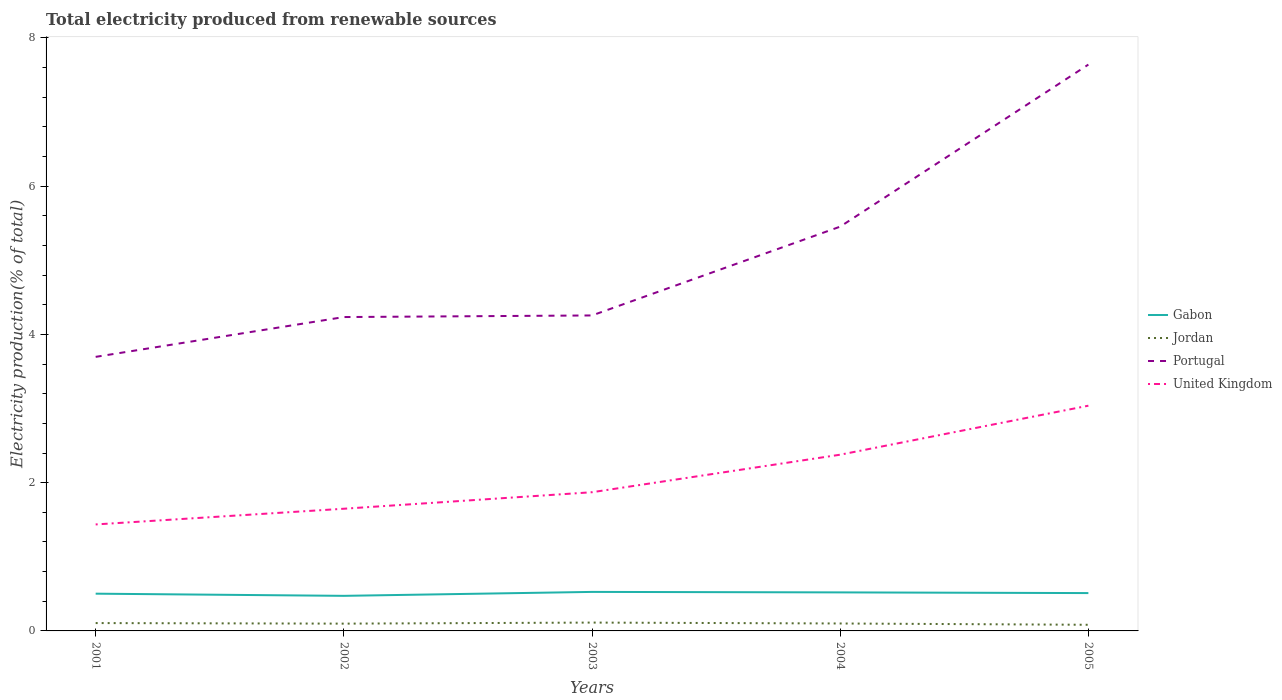How many different coloured lines are there?
Your answer should be compact. 4. Is the number of lines equal to the number of legend labels?
Make the answer very short. Yes. Across all years, what is the maximum total electricity produced in Jordan?
Give a very brief answer. 0.08. What is the total total electricity produced in Jordan in the graph?
Provide a short and direct response. 0.02. What is the difference between the highest and the second highest total electricity produced in Portugal?
Offer a terse response. 3.94. How many lines are there?
Provide a succinct answer. 4. How many years are there in the graph?
Make the answer very short. 5. How are the legend labels stacked?
Provide a succinct answer. Vertical. What is the title of the graph?
Your answer should be very brief. Total electricity produced from renewable sources. What is the label or title of the X-axis?
Provide a short and direct response. Years. What is the label or title of the Y-axis?
Your answer should be very brief. Electricity production(% of total). What is the Electricity production(% of total) of Gabon in 2001?
Your response must be concise. 0.5. What is the Electricity production(% of total) of Jordan in 2001?
Provide a short and direct response. 0.11. What is the Electricity production(% of total) in Portugal in 2001?
Give a very brief answer. 3.7. What is the Electricity production(% of total) in United Kingdom in 2001?
Ensure brevity in your answer.  1.44. What is the Electricity production(% of total) of Gabon in 2002?
Your response must be concise. 0.47. What is the Electricity production(% of total) of Jordan in 2002?
Make the answer very short. 0.1. What is the Electricity production(% of total) in Portugal in 2002?
Offer a very short reply. 4.23. What is the Electricity production(% of total) in United Kingdom in 2002?
Keep it short and to the point. 1.65. What is the Electricity production(% of total) of Gabon in 2003?
Offer a very short reply. 0.53. What is the Electricity production(% of total) of Jordan in 2003?
Your answer should be very brief. 0.11. What is the Electricity production(% of total) in Portugal in 2003?
Give a very brief answer. 4.26. What is the Electricity production(% of total) of United Kingdom in 2003?
Offer a terse response. 1.87. What is the Electricity production(% of total) in Gabon in 2004?
Provide a succinct answer. 0.52. What is the Electricity production(% of total) of Jordan in 2004?
Offer a terse response. 0.1. What is the Electricity production(% of total) in Portugal in 2004?
Offer a terse response. 5.45. What is the Electricity production(% of total) of United Kingdom in 2004?
Offer a terse response. 2.38. What is the Electricity production(% of total) of Gabon in 2005?
Provide a succinct answer. 0.51. What is the Electricity production(% of total) in Jordan in 2005?
Provide a short and direct response. 0.08. What is the Electricity production(% of total) of Portugal in 2005?
Your response must be concise. 7.64. What is the Electricity production(% of total) in United Kingdom in 2005?
Your answer should be very brief. 3.04. Across all years, what is the maximum Electricity production(% of total) of Gabon?
Provide a succinct answer. 0.53. Across all years, what is the maximum Electricity production(% of total) in Jordan?
Offer a very short reply. 0.11. Across all years, what is the maximum Electricity production(% of total) in Portugal?
Your answer should be compact. 7.64. Across all years, what is the maximum Electricity production(% of total) of United Kingdom?
Your response must be concise. 3.04. Across all years, what is the minimum Electricity production(% of total) in Gabon?
Offer a terse response. 0.47. Across all years, what is the minimum Electricity production(% of total) of Jordan?
Your answer should be compact. 0.08. Across all years, what is the minimum Electricity production(% of total) of Portugal?
Offer a very short reply. 3.7. Across all years, what is the minimum Electricity production(% of total) of United Kingdom?
Give a very brief answer. 1.44. What is the total Electricity production(% of total) in Gabon in the graph?
Ensure brevity in your answer.  2.53. What is the total Electricity production(% of total) in Jordan in the graph?
Provide a short and direct response. 0.5. What is the total Electricity production(% of total) in Portugal in the graph?
Your answer should be compact. 25.28. What is the total Electricity production(% of total) in United Kingdom in the graph?
Keep it short and to the point. 10.37. What is the difference between the Electricity production(% of total) in Gabon in 2001 and that in 2002?
Ensure brevity in your answer.  0.03. What is the difference between the Electricity production(% of total) of Jordan in 2001 and that in 2002?
Your answer should be very brief. 0.01. What is the difference between the Electricity production(% of total) of Portugal in 2001 and that in 2002?
Make the answer very short. -0.54. What is the difference between the Electricity production(% of total) in United Kingdom in 2001 and that in 2002?
Make the answer very short. -0.21. What is the difference between the Electricity production(% of total) of Gabon in 2001 and that in 2003?
Provide a succinct answer. -0.02. What is the difference between the Electricity production(% of total) of Jordan in 2001 and that in 2003?
Provide a succinct answer. -0.01. What is the difference between the Electricity production(% of total) of Portugal in 2001 and that in 2003?
Ensure brevity in your answer.  -0.56. What is the difference between the Electricity production(% of total) in United Kingdom in 2001 and that in 2003?
Your answer should be very brief. -0.43. What is the difference between the Electricity production(% of total) of Gabon in 2001 and that in 2004?
Offer a terse response. -0.02. What is the difference between the Electricity production(% of total) of Jordan in 2001 and that in 2004?
Make the answer very short. 0.01. What is the difference between the Electricity production(% of total) in Portugal in 2001 and that in 2004?
Give a very brief answer. -1.76. What is the difference between the Electricity production(% of total) of United Kingdom in 2001 and that in 2004?
Give a very brief answer. -0.94. What is the difference between the Electricity production(% of total) in Gabon in 2001 and that in 2005?
Provide a succinct answer. -0.01. What is the difference between the Electricity production(% of total) in Jordan in 2001 and that in 2005?
Keep it short and to the point. 0.02. What is the difference between the Electricity production(% of total) of Portugal in 2001 and that in 2005?
Your answer should be compact. -3.94. What is the difference between the Electricity production(% of total) in United Kingdom in 2001 and that in 2005?
Provide a succinct answer. -1.6. What is the difference between the Electricity production(% of total) in Gabon in 2002 and that in 2003?
Ensure brevity in your answer.  -0.05. What is the difference between the Electricity production(% of total) of Jordan in 2002 and that in 2003?
Your answer should be very brief. -0.01. What is the difference between the Electricity production(% of total) of Portugal in 2002 and that in 2003?
Keep it short and to the point. -0.02. What is the difference between the Electricity production(% of total) of United Kingdom in 2002 and that in 2003?
Keep it short and to the point. -0.22. What is the difference between the Electricity production(% of total) in Gabon in 2002 and that in 2004?
Your answer should be compact. -0.05. What is the difference between the Electricity production(% of total) in Jordan in 2002 and that in 2004?
Keep it short and to the point. -0. What is the difference between the Electricity production(% of total) in Portugal in 2002 and that in 2004?
Your answer should be very brief. -1.22. What is the difference between the Electricity production(% of total) in United Kingdom in 2002 and that in 2004?
Offer a terse response. -0.73. What is the difference between the Electricity production(% of total) of Gabon in 2002 and that in 2005?
Ensure brevity in your answer.  -0.04. What is the difference between the Electricity production(% of total) in Jordan in 2002 and that in 2005?
Provide a succinct answer. 0.02. What is the difference between the Electricity production(% of total) in Portugal in 2002 and that in 2005?
Your answer should be compact. -3.41. What is the difference between the Electricity production(% of total) in United Kingdom in 2002 and that in 2005?
Your answer should be compact. -1.39. What is the difference between the Electricity production(% of total) of Gabon in 2003 and that in 2004?
Provide a short and direct response. 0.01. What is the difference between the Electricity production(% of total) of Jordan in 2003 and that in 2004?
Ensure brevity in your answer.  0.01. What is the difference between the Electricity production(% of total) in Portugal in 2003 and that in 2004?
Keep it short and to the point. -1.2. What is the difference between the Electricity production(% of total) of United Kingdom in 2003 and that in 2004?
Provide a succinct answer. -0.51. What is the difference between the Electricity production(% of total) in Gabon in 2003 and that in 2005?
Your response must be concise. 0.02. What is the difference between the Electricity production(% of total) in Jordan in 2003 and that in 2005?
Provide a short and direct response. 0.03. What is the difference between the Electricity production(% of total) of Portugal in 2003 and that in 2005?
Provide a succinct answer. -3.38. What is the difference between the Electricity production(% of total) in United Kingdom in 2003 and that in 2005?
Your response must be concise. -1.17. What is the difference between the Electricity production(% of total) in Gabon in 2004 and that in 2005?
Ensure brevity in your answer.  0.01. What is the difference between the Electricity production(% of total) of Jordan in 2004 and that in 2005?
Your answer should be compact. 0.02. What is the difference between the Electricity production(% of total) in Portugal in 2004 and that in 2005?
Your response must be concise. -2.19. What is the difference between the Electricity production(% of total) in United Kingdom in 2004 and that in 2005?
Make the answer very short. -0.66. What is the difference between the Electricity production(% of total) in Gabon in 2001 and the Electricity production(% of total) in Jordan in 2002?
Your answer should be very brief. 0.4. What is the difference between the Electricity production(% of total) of Gabon in 2001 and the Electricity production(% of total) of Portugal in 2002?
Your answer should be compact. -3.73. What is the difference between the Electricity production(% of total) in Gabon in 2001 and the Electricity production(% of total) in United Kingdom in 2002?
Keep it short and to the point. -1.15. What is the difference between the Electricity production(% of total) of Jordan in 2001 and the Electricity production(% of total) of Portugal in 2002?
Ensure brevity in your answer.  -4.13. What is the difference between the Electricity production(% of total) in Jordan in 2001 and the Electricity production(% of total) in United Kingdom in 2002?
Offer a terse response. -1.54. What is the difference between the Electricity production(% of total) in Portugal in 2001 and the Electricity production(% of total) in United Kingdom in 2002?
Make the answer very short. 2.05. What is the difference between the Electricity production(% of total) of Gabon in 2001 and the Electricity production(% of total) of Jordan in 2003?
Keep it short and to the point. 0.39. What is the difference between the Electricity production(% of total) in Gabon in 2001 and the Electricity production(% of total) in Portugal in 2003?
Ensure brevity in your answer.  -3.75. What is the difference between the Electricity production(% of total) of Gabon in 2001 and the Electricity production(% of total) of United Kingdom in 2003?
Provide a short and direct response. -1.37. What is the difference between the Electricity production(% of total) of Jordan in 2001 and the Electricity production(% of total) of Portugal in 2003?
Offer a terse response. -4.15. What is the difference between the Electricity production(% of total) in Jordan in 2001 and the Electricity production(% of total) in United Kingdom in 2003?
Make the answer very short. -1.77. What is the difference between the Electricity production(% of total) of Portugal in 2001 and the Electricity production(% of total) of United Kingdom in 2003?
Provide a succinct answer. 1.83. What is the difference between the Electricity production(% of total) of Gabon in 2001 and the Electricity production(% of total) of Jordan in 2004?
Make the answer very short. 0.4. What is the difference between the Electricity production(% of total) of Gabon in 2001 and the Electricity production(% of total) of Portugal in 2004?
Your answer should be very brief. -4.95. What is the difference between the Electricity production(% of total) of Gabon in 2001 and the Electricity production(% of total) of United Kingdom in 2004?
Give a very brief answer. -1.88. What is the difference between the Electricity production(% of total) of Jordan in 2001 and the Electricity production(% of total) of Portugal in 2004?
Keep it short and to the point. -5.35. What is the difference between the Electricity production(% of total) of Jordan in 2001 and the Electricity production(% of total) of United Kingdom in 2004?
Make the answer very short. -2.27. What is the difference between the Electricity production(% of total) in Portugal in 2001 and the Electricity production(% of total) in United Kingdom in 2004?
Ensure brevity in your answer.  1.32. What is the difference between the Electricity production(% of total) of Gabon in 2001 and the Electricity production(% of total) of Jordan in 2005?
Offer a terse response. 0.42. What is the difference between the Electricity production(% of total) in Gabon in 2001 and the Electricity production(% of total) in Portugal in 2005?
Keep it short and to the point. -7.14. What is the difference between the Electricity production(% of total) of Gabon in 2001 and the Electricity production(% of total) of United Kingdom in 2005?
Make the answer very short. -2.54. What is the difference between the Electricity production(% of total) in Jordan in 2001 and the Electricity production(% of total) in Portugal in 2005?
Give a very brief answer. -7.53. What is the difference between the Electricity production(% of total) of Jordan in 2001 and the Electricity production(% of total) of United Kingdom in 2005?
Your answer should be compact. -2.93. What is the difference between the Electricity production(% of total) in Portugal in 2001 and the Electricity production(% of total) in United Kingdom in 2005?
Provide a succinct answer. 0.66. What is the difference between the Electricity production(% of total) of Gabon in 2002 and the Electricity production(% of total) of Jordan in 2003?
Keep it short and to the point. 0.36. What is the difference between the Electricity production(% of total) of Gabon in 2002 and the Electricity production(% of total) of Portugal in 2003?
Provide a succinct answer. -3.78. What is the difference between the Electricity production(% of total) of Gabon in 2002 and the Electricity production(% of total) of United Kingdom in 2003?
Make the answer very short. -1.4. What is the difference between the Electricity production(% of total) in Jordan in 2002 and the Electricity production(% of total) in Portugal in 2003?
Provide a succinct answer. -4.16. What is the difference between the Electricity production(% of total) of Jordan in 2002 and the Electricity production(% of total) of United Kingdom in 2003?
Your answer should be very brief. -1.77. What is the difference between the Electricity production(% of total) of Portugal in 2002 and the Electricity production(% of total) of United Kingdom in 2003?
Provide a short and direct response. 2.36. What is the difference between the Electricity production(% of total) in Gabon in 2002 and the Electricity production(% of total) in Jordan in 2004?
Keep it short and to the point. 0.37. What is the difference between the Electricity production(% of total) in Gabon in 2002 and the Electricity production(% of total) in Portugal in 2004?
Your answer should be very brief. -4.98. What is the difference between the Electricity production(% of total) in Gabon in 2002 and the Electricity production(% of total) in United Kingdom in 2004?
Your answer should be very brief. -1.9. What is the difference between the Electricity production(% of total) of Jordan in 2002 and the Electricity production(% of total) of Portugal in 2004?
Make the answer very short. -5.36. What is the difference between the Electricity production(% of total) of Jordan in 2002 and the Electricity production(% of total) of United Kingdom in 2004?
Your response must be concise. -2.28. What is the difference between the Electricity production(% of total) in Portugal in 2002 and the Electricity production(% of total) in United Kingdom in 2004?
Make the answer very short. 1.86. What is the difference between the Electricity production(% of total) in Gabon in 2002 and the Electricity production(% of total) in Jordan in 2005?
Offer a very short reply. 0.39. What is the difference between the Electricity production(% of total) of Gabon in 2002 and the Electricity production(% of total) of Portugal in 2005?
Offer a very short reply. -7.17. What is the difference between the Electricity production(% of total) of Gabon in 2002 and the Electricity production(% of total) of United Kingdom in 2005?
Give a very brief answer. -2.57. What is the difference between the Electricity production(% of total) of Jordan in 2002 and the Electricity production(% of total) of Portugal in 2005?
Provide a short and direct response. -7.54. What is the difference between the Electricity production(% of total) of Jordan in 2002 and the Electricity production(% of total) of United Kingdom in 2005?
Keep it short and to the point. -2.94. What is the difference between the Electricity production(% of total) in Portugal in 2002 and the Electricity production(% of total) in United Kingdom in 2005?
Keep it short and to the point. 1.2. What is the difference between the Electricity production(% of total) of Gabon in 2003 and the Electricity production(% of total) of Jordan in 2004?
Ensure brevity in your answer.  0.43. What is the difference between the Electricity production(% of total) in Gabon in 2003 and the Electricity production(% of total) in Portugal in 2004?
Offer a terse response. -4.93. What is the difference between the Electricity production(% of total) in Gabon in 2003 and the Electricity production(% of total) in United Kingdom in 2004?
Keep it short and to the point. -1.85. What is the difference between the Electricity production(% of total) of Jordan in 2003 and the Electricity production(% of total) of Portugal in 2004?
Give a very brief answer. -5.34. What is the difference between the Electricity production(% of total) of Jordan in 2003 and the Electricity production(% of total) of United Kingdom in 2004?
Provide a succinct answer. -2.27. What is the difference between the Electricity production(% of total) in Portugal in 2003 and the Electricity production(% of total) in United Kingdom in 2004?
Offer a very short reply. 1.88. What is the difference between the Electricity production(% of total) in Gabon in 2003 and the Electricity production(% of total) in Jordan in 2005?
Give a very brief answer. 0.44. What is the difference between the Electricity production(% of total) of Gabon in 2003 and the Electricity production(% of total) of Portugal in 2005?
Your response must be concise. -7.11. What is the difference between the Electricity production(% of total) of Gabon in 2003 and the Electricity production(% of total) of United Kingdom in 2005?
Provide a succinct answer. -2.51. What is the difference between the Electricity production(% of total) of Jordan in 2003 and the Electricity production(% of total) of Portugal in 2005?
Offer a very short reply. -7.53. What is the difference between the Electricity production(% of total) in Jordan in 2003 and the Electricity production(% of total) in United Kingdom in 2005?
Provide a succinct answer. -2.93. What is the difference between the Electricity production(% of total) of Portugal in 2003 and the Electricity production(% of total) of United Kingdom in 2005?
Your answer should be very brief. 1.22. What is the difference between the Electricity production(% of total) in Gabon in 2004 and the Electricity production(% of total) in Jordan in 2005?
Your answer should be compact. 0.44. What is the difference between the Electricity production(% of total) in Gabon in 2004 and the Electricity production(% of total) in Portugal in 2005?
Provide a succinct answer. -7.12. What is the difference between the Electricity production(% of total) of Gabon in 2004 and the Electricity production(% of total) of United Kingdom in 2005?
Your response must be concise. -2.52. What is the difference between the Electricity production(% of total) of Jordan in 2004 and the Electricity production(% of total) of Portugal in 2005?
Offer a terse response. -7.54. What is the difference between the Electricity production(% of total) of Jordan in 2004 and the Electricity production(% of total) of United Kingdom in 2005?
Provide a short and direct response. -2.94. What is the difference between the Electricity production(% of total) of Portugal in 2004 and the Electricity production(% of total) of United Kingdom in 2005?
Offer a very short reply. 2.42. What is the average Electricity production(% of total) in Gabon per year?
Keep it short and to the point. 0.51. What is the average Electricity production(% of total) in Jordan per year?
Your response must be concise. 0.1. What is the average Electricity production(% of total) in Portugal per year?
Provide a short and direct response. 5.06. What is the average Electricity production(% of total) of United Kingdom per year?
Provide a short and direct response. 2.07. In the year 2001, what is the difference between the Electricity production(% of total) in Gabon and Electricity production(% of total) in Jordan?
Make the answer very short. 0.4. In the year 2001, what is the difference between the Electricity production(% of total) in Gabon and Electricity production(% of total) in Portugal?
Provide a short and direct response. -3.19. In the year 2001, what is the difference between the Electricity production(% of total) of Gabon and Electricity production(% of total) of United Kingdom?
Keep it short and to the point. -0.93. In the year 2001, what is the difference between the Electricity production(% of total) of Jordan and Electricity production(% of total) of Portugal?
Keep it short and to the point. -3.59. In the year 2001, what is the difference between the Electricity production(% of total) in Jordan and Electricity production(% of total) in United Kingdom?
Your answer should be compact. -1.33. In the year 2001, what is the difference between the Electricity production(% of total) in Portugal and Electricity production(% of total) in United Kingdom?
Keep it short and to the point. 2.26. In the year 2002, what is the difference between the Electricity production(% of total) in Gabon and Electricity production(% of total) in Jordan?
Provide a short and direct response. 0.37. In the year 2002, what is the difference between the Electricity production(% of total) of Gabon and Electricity production(% of total) of Portugal?
Offer a terse response. -3.76. In the year 2002, what is the difference between the Electricity production(% of total) of Gabon and Electricity production(% of total) of United Kingdom?
Your answer should be compact. -1.18. In the year 2002, what is the difference between the Electricity production(% of total) of Jordan and Electricity production(% of total) of Portugal?
Keep it short and to the point. -4.14. In the year 2002, what is the difference between the Electricity production(% of total) in Jordan and Electricity production(% of total) in United Kingdom?
Keep it short and to the point. -1.55. In the year 2002, what is the difference between the Electricity production(% of total) of Portugal and Electricity production(% of total) of United Kingdom?
Provide a succinct answer. 2.59. In the year 2003, what is the difference between the Electricity production(% of total) of Gabon and Electricity production(% of total) of Jordan?
Give a very brief answer. 0.41. In the year 2003, what is the difference between the Electricity production(% of total) in Gabon and Electricity production(% of total) in Portugal?
Your response must be concise. -3.73. In the year 2003, what is the difference between the Electricity production(% of total) in Gabon and Electricity production(% of total) in United Kingdom?
Give a very brief answer. -1.34. In the year 2003, what is the difference between the Electricity production(% of total) in Jordan and Electricity production(% of total) in Portugal?
Your answer should be very brief. -4.14. In the year 2003, what is the difference between the Electricity production(% of total) of Jordan and Electricity production(% of total) of United Kingdom?
Give a very brief answer. -1.76. In the year 2003, what is the difference between the Electricity production(% of total) in Portugal and Electricity production(% of total) in United Kingdom?
Provide a succinct answer. 2.38. In the year 2004, what is the difference between the Electricity production(% of total) of Gabon and Electricity production(% of total) of Jordan?
Your response must be concise. 0.42. In the year 2004, what is the difference between the Electricity production(% of total) in Gabon and Electricity production(% of total) in Portugal?
Keep it short and to the point. -4.93. In the year 2004, what is the difference between the Electricity production(% of total) of Gabon and Electricity production(% of total) of United Kingdom?
Make the answer very short. -1.86. In the year 2004, what is the difference between the Electricity production(% of total) in Jordan and Electricity production(% of total) in Portugal?
Provide a short and direct response. -5.35. In the year 2004, what is the difference between the Electricity production(% of total) in Jordan and Electricity production(% of total) in United Kingdom?
Provide a succinct answer. -2.28. In the year 2004, what is the difference between the Electricity production(% of total) in Portugal and Electricity production(% of total) in United Kingdom?
Provide a short and direct response. 3.08. In the year 2005, what is the difference between the Electricity production(% of total) in Gabon and Electricity production(% of total) in Jordan?
Provide a succinct answer. 0.43. In the year 2005, what is the difference between the Electricity production(% of total) in Gabon and Electricity production(% of total) in Portugal?
Give a very brief answer. -7.13. In the year 2005, what is the difference between the Electricity production(% of total) in Gabon and Electricity production(% of total) in United Kingdom?
Offer a terse response. -2.53. In the year 2005, what is the difference between the Electricity production(% of total) in Jordan and Electricity production(% of total) in Portugal?
Your response must be concise. -7.56. In the year 2005, what is the difference between the Electricity production(% of total) of Jordan and Electricity production(% of total) of United Kingdom?
Provide a succinct answer. -2.96. In the year 2005, what is the difference between the Electricity production(% of total) in Portugal and Electricity production(% of total) in United Kingdom?
Your response must be concise. 4.6. What is the ratio of the Electricity production(% of total) in Gabon in 2001 to that in 2002?
Your response must be concise. 1.06. What is the ratio of the Electricity production(% of total) of Jordan in 2001 to that in 2002?
Ensure brevity in your answer.  1.08. What is the ratio of the Electricity production(% of total) in Portugal in 2001 to that in 2002?
Make the answer very short. 0.87. What is the ratio of the Electricity production(% of total) in United Kingdom in 2001 to that in 2002?
Give a very brief answer. 0.87. What is the ratio of the Electricity production(% of total) in Gabon in 2001 to that in 2003?
Your answer should be compact. 0.95. What is the ratio of the Electricity production(% of total) in Jordan in 2001 to that in 2003?
Give a very brief answer. 0.94. What is the ratio of the Electricity production(% of total) of Portugal in 2001 to that in 2003?
Ensure brevity in your answer.  0.87. What is the ratio of the Electricity production(% of total) of United Kingdom in 2001 to that in 2003?
Make the answer very short. 0.77. What is the ratio of the Electricity production(% of total) of Gabon in 2001 to that in 2004?
Your response must be concise. 0.97. What is the ratio of the Electricity production(% of total) in Jordan in 2001 to that in 2004?
Keep it short and to the point. 1.06. What is the ratio of the Electricity production(% of total) of Portugal in 2001 to that in 2004?
Your answer should be compact. 0.68. What is the ratio of the Electricity production(% of total) in United Kingdom in 2001 to that in 2004?
Your answer should be compact. 0.6. What is the ratio of the Electricity production(% of total) of Gabon in 2001 to that in 2005?
Your answer should be compact. 0.98. What is the ratio of the Electricity production(% of total) of Jordan in 2001 to that in 2005?
Offer a terse response. 1.28. What is the ratio of the Electricity production(% of total) in Portugal in 2001 to that in 2005?
Your response must be concise. 0.48. What is the ratio of the Electricity production(% of total) in United Kingdom in 2001 to that in 2005?
Your answer should be very brief. 0.47. What is the ratio of the Electricity production(% of total) in Gabon in 2002 to that in 2003?
Offer a terse response. 0.9. What is the ratio of the Electricity production(% of total) of Jordan in 2002 to that in 2003?
Provide a short and direct response. 0.87. What is the ratio of the Electricity production(% of total) in United Kingdom in 2002 to that in 2003?
Provide a succinct answer. 0.88. What is the ratio of the Electricity production(% of total) in Gabon in 2002 to that in 2004?
Ensure brevity in your answer.  0.91. What is the ratio of the Electricity production(% of total) in Jordan in 2002 to that in 2004?
Offer a terse response. 0.98. What is the ratio of the Electricity production(% of total) in Portugal in 2002 to that in 2004?
Your answer should be very brief. 0.78. What is the ratio of the Electricity production(% of total) of United Kingdom in 2002 to that in 2004?
Provide a short and direct response. 0.69. What is the ratio of the Electricity production(% of total) of Gabon in 2002 to that in 2005?
Your response must be concise. 0.93. What is the ratio of the Electricity production(% of total) in Jordan in 2002 to that in 2005?
Your answer should be compact. 1.19. What is the ratio of the Electricity production(% of total) of Portugal in 2002 to that in 2005?
Your answer should be compact. 0.55. What is the ratio of the Electricity production(% of total) in United Kingdom in 2002 to that in 2005?
Ensure brevity in your answer.  0.54. What is the ratio of the Electricity production(% of total) of Gabon in 2003 to that in 2004?
Offer a terse response. 1.01. What is the ratio of the Electricity production(% of total) of Jordan in 2003 to that in 2004?
Offer a very short reply. 1.12. What is the ratio of the Electricity production(% of total) in Portugal in 2003 to that in 2004?
Make the answer very short. 0.78. What is the ratio of the Electricity production(% of total) of United Kingdom in 2003 to that in 2004?
Provide a succinct answer. 0.79. What is the ratio of the Electricity production(% of total) in Gabon in 2003 to that in 2005?
Keep it short and to the point. 1.03. What is the ratio of the Electricity production(% of total) of Jordan in 2003 to that in 2005?
Give a very brief answer. 1.36. What is the ratio of the Electricity production(% of total) in Portugal in 2003 to that in 2005?
Offer a terse response. 0.56. What is the ratio of the Electricity production(% of total) in United Kingdom in 2003 to that in 2005?
Your answer should be very brief. 0.62. What is the ratio of the Electricity production(% of total) in Gabon in 2004 to that in 2005?
Provide a succinct answer. 1.02. What is the ratio of the Electricity production(% of total) in Jordan in 2004 to that in 2005?
Offer a terse response. 1.21. What is the ratio of the Electricity production(% of total) in Portugal in 2004 to that in 2005?
Provide a short and direct response. 0.71. What is the ratio of the Electricity production(% of total) in United Kingdom in 2004 to that in 2005?
Offer a terse response. 0.78. What is the difference between the highest and the second highest Electricity production(% of total) in Gabon?
Ensure brevity in your answer.  0.01. What is the difference between the highest and the second highest Electricity production(% of total) of Jordan?
Keep it short and to the point. 0.01. What is the difference between the highest and the second highest Electricity production(% of total) in Portugal?
Give a very brief answer. 2.19. What is the difference between the highest and the second highest Electricity production(% of total) in United Kingdom?
Give a very brief answer. 0.66. What is the difference between the highest and the lowest Electricity production(% of total) in Gabon?
Give a very brief answer. 0.05. What is the difference between the highest and the lowest Electricity production(% of total) in Jordan?
Provide a succinct answer. 0.03. What is the difference between the highest and the lowest Electricity production(% of total) in Portugal?
Your answer should be very brief. 3.94. What is the difference between the highest and the lowest Electricity production(% of total) of United Kingdom?
Your response must be concise. 1.6. 